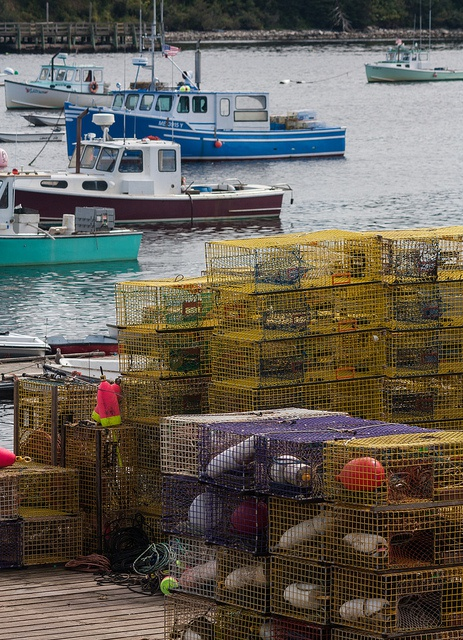Describe the objects in this image and their specific colors. I can see boat in black, darkgray, lightgray, and gray tones, boat in black, darkgray, blue, and darkblue tones, boat in black, darkgray, gray, and lightgray tones, boat in black, darkgray, and gray tones, and boat in black, teal, and darkgray tones in this image. 